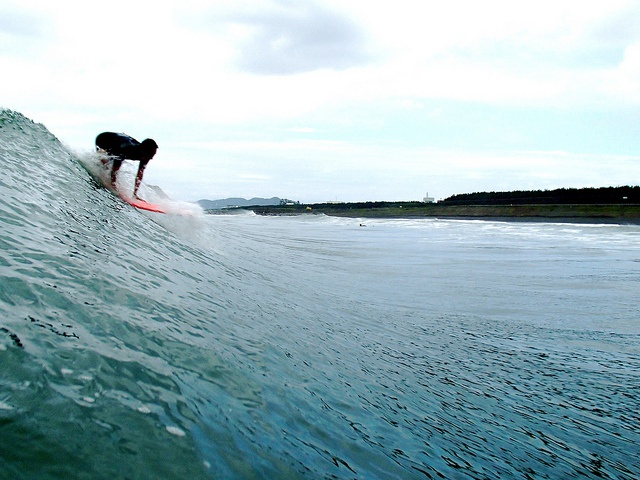Describe the objects in this image and their specific colors. I can see people in white, black, darkgray, lightgray, and gray tones and surfboard in white, lightgray, lightpink, darkgray, and gray tones in this image. 